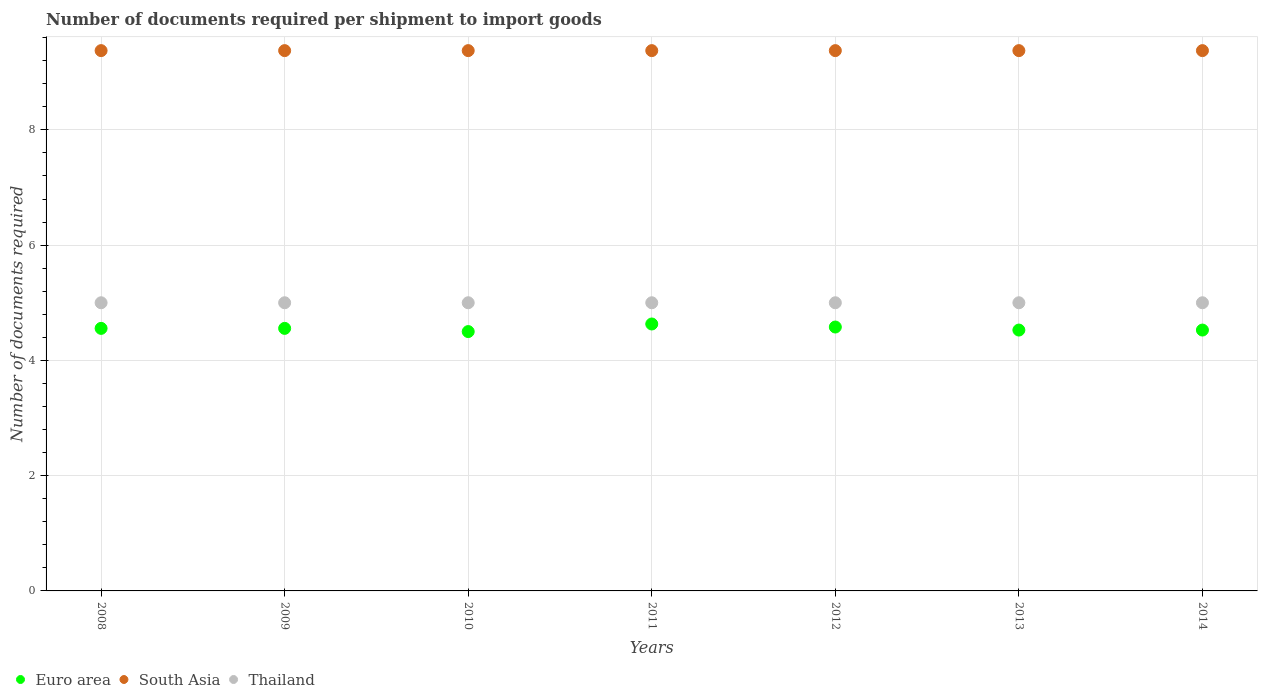How many different coloured dotlines are there?
Provide a succinct answer. 3. Is the number of dotlines equal to the number of legend labels?
Keep it short and to the point. Yes. What is the number of documents required per shipment to import goods in South Asia in 2013?
Offer a very short reply. 9.38. Across all years, what is the maximum number of documents required per shipment to import goods in South Asia?
Keep it short and to the point. 9.38. Across all years, what is the minimum number of documents required per shipment to import goods in Euro area?
Your answer should be very brief. 4.5. In which year was the number of documents required per shipment to import goods in South Asia maximum?
Ensure brevity in your answer.  2008. In which year was the number of documents required per shipment to import goods in Thailand minimum?
Make the answer very short. 2008. What is the total number of documents required per shipment to import goods in Thailand in the graph?
Give a very brief answer. 35. What is the difference between the number of documents required per shipment to import goods in Thailand in 2014 and the number of documents required per shipment to import goods in South Asia in 2012?
Your response must be concise. -4.38. What is the average number of documents required per shipment to import goods in Euro area per year?
Your answer should be very brief. 4.55. In the year 2012, what is the difference between the number of documents required per shipment to import goods in Thailand and number of documents required per shipment to import goods in South Asia?
Make the answer very short. -4.38. In how many years, is the number of documents required per shipment to import goods in Euro area greater than 2?
Offer a terse response. 7. Is the difference between the number of documents required per shipment to import goods in Thailand in 2008 and 2014 greater than the difference between the number of documents required per shipment to import goods in South Asia in 2008 and 2014?
Keep it short and to the point. No. What is the difference between the highest and the second highest number of documents required per shipment to import goods in Thailand?
Your answer should be compact. 0. Is the sum of the number of documents required per shipment to import goods in Thailand in 2008 and 2010 greater than the maximum number of documents required per shipment to import goods in South Asia across all years?
Ensure brevity in your answer.  Yes. Does the number of documents required per shipment to import goods in Thailand monotonically increase over the years?
Your response must be concise. No. What is the difference between two consecutive major ticks on the Y-axis?
Provide a short and direct response. 2. Does the graph contain grids?
Make the answer very short. Yes. How many legend labels are there?
Provide a short and direct response. 3. How are the legend labels stacked?
Your response must be concise. Horizontal. What is the title of the graph?
Your answer should be very brief. Number of documents required per shipment to import goods. Does "Rwanda" appear as one of the legend labels in the graph?
Your answer should be very brief. No. What is the label or title of the X-axis?
Offer a very short reply. Years. What is the label or title of the Y-axis?
Give a very brief answer. Number of documents required. What is the Number of documents required of Euro area in 2008?
Your answer should be compact. 4.56. What is the Number of documents required of South Asia in 2008?
Provide a short and direct response. 9.38. What is the Number of documents required in Thailand in 2008?
Your response must be concise. 5. What is the Number of documents required of Euro area in 2009?
Your answer should be very brief. 4.56. What is the Number of documents required in South Asia in 2009?
Ensure brevity in your answer.  9.38. What is the Number of documents required of South Asia in 2010?
Offer a terse response. 9.38. What is the Number of documents required of Euro area in 2011?
Your answer should be very brief. 4.63. What is the Number of documents required of South Asia in 2011?
Keep it short and to the point. 9.38. What is the Number of documents required in Euro area in 2012?
Provide a short and direct response. 4.58. What is the Number of documents required in South Asia in 2012?
Your response must be concise. 9.38. What is the Number of documents required of Euro area in 2013?
Keep it short and to the point. 4.53. What is the Number of documents required in South Asia in 2013?
Make the answer very short. 9.38. What is the Number of documents required in Euro area in 2014?
Ensure brevity in your answer.  4.53. What is the Number of documents required in South Asia in 2014?
Provide a succinct answer. 9.38. Across all years, what is the maximum Number of documents required in Euro area?
Your answer should be very brief. 4.63. Across all years, what is the maximum Number of documents required of South Asia?
Provide a short and direct response. 9.38. Across all years, what is the minimum Number of documents required in South Asia?
Give a very brief answer. 9.38. Across all years, what is the minimum Number of documents required of Thailand?
Offer a very short reply. 5. What is the total Number of documents required in Euro area in the graph?
Provide a short and direct response. 31.87. What is the total Number of documents required in South Asia in the graph?
Provide a short and direct response. 65.62. What is the total Number of documents required of Thailand in the graph?
Give a very brief answer. 35. What is the difference between the Number of documents required in South Asia in 2008 and that in 2009?
Keep it short and to the point. 0. What is the difference between the Number of documents required of Euro area in 2008 and that in 2010?
Your answer should be very brief. 0.06. What is the difference between the Number of documents required in Thailand in 2008 and that in 2010?
Provide a short and direct response. 0. What is the difference between the Number of documents required of Euro area in 2008 and that in 2011?
Ensure brevity in your answer.  -0.08. What is the difference between the Number of documents required in South Asia in 2008 and that in 2011?
Keep it short and to the point. 0. What is the difference between the Number of documents required in Euro area in 2008 and that in 2012?
Ensure brevity in your answer.  -0.02. What is the difference between the Number of documents required in South Asia in 2008 and that in 2012?
Give a very brief answer. 0. What is the difference between the Number of documents required in Thailand in 2008 and that in 2012?
Offer a terse response. 0. What is the difference between the Number of documents required in Euro area in 2008 and that in 2013?
Make the answer very short. 0.03. What is the difference between the Number of documents required of Euro area in 2008 and that in 2014?
Provide a succinct answer. 0.03. What is the difference between the Number of documents required in South Asia in 2008 and that in 2014?
Your answer should be compact. 0. What is the difference between the Number of documents required in Euro area in 2009 and that in 2010?
Keep it short and to the point. 0.06. What is the difference between the Number of documents required of South Asia in 2009 and that in 2010?
Make the answer very short. 0. What is the difference between the Number of documents required in Euro area in 2009 and that in 2011?
Keep it short and to the point. -0.08. What is the difference between the Number of documents required of South Asia in 2009 and that in 2011?
Keep it short and to the point. 0. What is the difference between the Number of documents required of Euro area in 2009 and that in 2012?
Your response must be concise. -0.02. What is the difference between the Number of documents required of Thailand in 2009 and that in 2012?
Make the answer very short. 0. What is the difference between the Number of documents required of Euro area in 2009 and that in 2013?
Your answer should be very brief. 0.03. What is the difference between the Number of documents required of Euro area in 2009 and that in 2014?
Offer a very short reply. 0.03. What is the difference between the Number of documents required of South Asia in 2009 and that in 2014?
Ensure brevity in your answer.  0. What is the difference between the Number of documents required in Thailand in 2009 and that in 2014?
Offer a very short reply. 0. What is the difference between the Number of documents required of Euro area in 2010 and that in 2011?
Make the answer very short. -0.13. What is the difference between the Number of documents required in Thailand in 2010 and that in 2011?
Ensure brevity in your answer.  0. What is the difference between the Number of documents required in Euro area in 2010 and that in 2012?
Offer a very short reply. -0.08. What is the difference between the Number of documents required of Euro area in 2010 and that in 2013?
Keep it short and to the point. -0.03. What is the difference between the Number of documents required in Thailand in 2010 and that in 2013?
Offer a very short reply. 0. What is the difference between the Number of documents required of Euro area in 2010 and that in 2014?
Offer a terse response. -0.03. What is the difference between the Number of documents required of South Asia in 2010 and that in 2014?
Ensure brevity in your answer.  0. What is the difference between the Number of documents required of Thailand in 2010 and that in 2014?
Offer a very short reply. 0. What is the difference between the Number of documents required of Euro area in 2011 and that in 2012?
Offer a terse response. 0.05. What is the difference between the Number of documents required of South Asia in 2011 and that in 2012?
Provide a short and direct response. 0. What is the difference between the Number of documents required of Euro area in 2011 and that in 2013?
Give a very brief answer. 0.11. What is the difference between the Number of documents required in South Asia in 2011 and that in 2013?
Your answer should be compact. 0. What is the difference between the Number of documents required in Euro area in 2011 and that in 2014?
Give a very brief answer. 0.11. What is the difference between the Number of documents required in South Asia in 2011 and that in 2014?
Keep it short and to the point. 0. What is the difference between the Number of documents required of Euro area in 2012 and that in 2013?
Your response must be concise. 0.05. What is the difference between the Number of documents required of South Asia in 2012 and that in 2013?
Provide a short and direct response. 0. What is the difference between the Number of documents required in Euro area in 2012 and that in 2014?
Offer a very short reply. 0.05. What is the difference between the Number of documents required of South Asia in 2013 and that in 2014?
Provide a succinct answer. 0. What is the difference between the Number of documents required of Thailand in 2013 and that in 2014?
Ensure brevity in your answer.  0. What is the difference between the Number of documents required in Euro area in 2008 and the Number of documents required in South Asia in 2009?
Provide a short and direct response. -4.82. What is the difference between the Number of documents required in Euro area in 2008 and the Number of documents required in Thailand in 2009?
Give a very brief answer. -0.44. What is the difference between the Number of documents required of South Asia in 2008 and the Number of documents required of Thailand in 2009?
Your response must be concise. 4.38. What is the difference between the Number of documents required in Euro area in 2008 and the Number of documents required in South Asia in 2010?
Make the answer very short. -4.82. What is the difference between the Number of documents required of Euro area in 2008 and the Number of documents required of Thailand in 2010?
Ensure brevity in your answer.  -0.44. What is the difference between the Number of documents required in South Asia in 2008 and the Number of documents required in Thailand in 2010?
Provide a short and direct response. 4.38. What is the difference between the Number of documents required of Euro area in 2008 and the Number of documents required of South Asia in 2011?
Your answer should be compact. -4.82. What is the difference between the Number of documents required of Euro area in 2008 and the Number of documents required of Thailand in 2011?
Your response must be concise. -0.44. What is the difference between the Number of documents required in South Asia in 2008 and the Number of documents required in Thailand in 2011?
Provide a succinct answer. 4.38. What is the difference between the Number of documents required in Euro area in 2008 and the Number of documents required in South Asia in 2012?
Provide a short and direct response. -4.82. What is the difference between the Number of documents required in Euro area in 2008 and the Number of documents required in Thailand in 2012?
Offer a terse response. -0.44. What is the difference between the Number of documents required of South Asia in 2008 and the Number of documents required of Thailand in 2012?
Provide a short and direct response. 4.38. What is the difference between the Number of documents required in Euro area in 2008 and the Number of documents required in South Asia in 2013?
Give a very brief answer. -4.82. What is the difference between the Number of documents required in Euro area in 2008 and the Number of documents required in Thailand in 2013?
Give a very brief answer. -0.44. What is the difference between the Number of documents required in South Asia in 2008 and the Number of documents required in Thailand in 2013?
Keep it short and to the point. 4.38. What is the difference between the Number of documents required of Euro area in 2008 and the Number of documents required of South Asia in 2014?
Ensure brevity in your answer.  -4.82. What is the difference between the Number of documents required of Euro area in 2008 and the Number of documents required of Thailand in 2014?
Your answer should be very brief. -0.44. What is the difference between the Number of documents required of South Asia in 2008 and the Number of documents required of Thailand in 2014?
Give a very brief answer. 4.38. What is the difference between the Number of documents required in Euro area in 2009 and the Number of documents required in South Asia in 2010?
Offer a very short reply. -4.82. What is the difference between the Number of documents required of Euro area in 2009 and the Number of documents required of Thailand in 2010?
Offer a terse response. -0.44. What is the difference between the Number of documents required in South Asia in 2009 and the Number of documents required in Thailand in 2010?
Provide a succinct answer. 4.38. What is the difference between the Number of documents required of Euro area in 2009 and the Number of documents required of South Asia in 2011?
Your response must be concise. -4.82. What is the difference between the Number of documents required of Euro area in 2009 and the Number of documents required of Thailand in 2011?
Offer a very short reply. -0.44. What is the difference between the Number of documents required of South Asia in 2009 and the Number of documents required of Thailand in 2011?
Your answer should be compact. 4.38. What is the difference between the Number of documents required in Euro area in 2009 and the Number of documents required in South Asia in 2012?
Ensure brevity in your answer.  -4.82. What is the difference between the Number of documents required in Euro area in 2009 and the Number of documents required in Thailand in 2012?
Provide a succinct answer. -0.44. What is the difference between the Number of documents required in South Asia in 2009 and the Number of documents required in Thailand in 2012?
Your response must be concise. 4.38. What is the difference between the Number of documents required in Euro area in 2009 and the Number of documents required in South Asia in 2013?
Provide a short and direct response. -4.82. What is the difference between the Number of documents required of Euro area in 2009 and the Number of documents required of Thailand in 2013?
Offer a very short reply. -0.44. What is the difference between the Number of documents required in South Asia in 2009 and the Number of documents required in Thailand in 2013?
Ensure brevity in your answer.  4.38. What is the difference between the Number of documents required of Euro area in 2009 and the Number of documents required of South Asia in 2014?
Keep it short and to the point. -4.82. What is the difference between the Number of documents required of Euro area in 2009 and the Number of documents required of Thailand in 2014?
Offer a terse response. -0.44. What is the difference between the Number of documents required in South Asia in 2009 and the Number of documents required in Thailand in 2014?
Provide a short and direct response. 4.38. What is the difference between the Number of documents required of Euro area in 2010 and the Number of documents required of South Asia in 2011?
Offer a very short reply. -4.88. What is the difference between the Number of documents required in Euro area in 2010 and the Number of documents required in Thailand in 2011?
Offer a terse response. -0.5. What is the difference between the Number of documents required in South Asia in 2010 and the Number of documents required in Thailand in 2011?
Offer a very short reply. 4.38. What is the difference between the Number of documents required in Euro area in 2010 and the Number of documents required in South Asia in 2012?
Provide a short and direct response. -4.88. What is the difference between the Number of documents required of South Asia in 2010 and the Number of documents required of Thailand in 2012?
Keep it short and to the point. 4.38. What is the difference between the Number of documents required in Euro area in 2010 and the Number of documents required in South Asia in 2013?
Ensure brevity in your answer.  -4.88. What is the difference between the Number of documents required in Euro area in 2010 and the Number of documents required in Thailand in 2013?
Your answer should be very brief. -0.5. What is the difference between the Number of documents required in South Asia in 2010 and the Number of documents required in Thailand in 2013?
Make the answer very short. 4.38. What is the difference between the Number of documents required in Euro area in 2010 and the Number of documents required in South Asia in 2014?
Give a very brief answer. -4.88. What is the difference between the Number of documents required in South Asia in 2010 and the Number of documents required in Thailand in 2014?
Keep it short and to the point. 4.38. What is the difference between the Number of documents required of Euro area in 2011 and the Number of documents required of South Asia in 2012?
Provide a succinct answer. -4.74. What is the difference between the Number of documents required in Euro area in 2011 and the Number of documents required in Thailand in 2012?
Offer a very short reply. -0.37. What is the difference between the Number of documents required of South Asia in 2011 and the Number of documents required of Thailand in 2012?
Offer a very short reply. 4.38. What is the difference between the Number of documents required of Euro area in 2011 and the Number of documents required of South Asia in 2013?
Provide a succinct answer. -4.74. What is the difference between the Number of documents required in Euro area in 2011 and the Number of documents required in Thailand in 2013?
Your answer should be compact. -0.37. What is the difference between the Number of documents required in South Asia in 2011 and the Number of documents required in Thailand in 2013?
Your answer should be compact. 4.38. What is the difference between the Number of documents required in Euro area in 2011 and the Number of documents required in South Asia in 2014?
Provide a short and direct response. -4.74. What is the difference between the Number of documents required of Euro area in 2011 and the Number of documents required of Thailand in 2014?
Your answer should be compact. -0.37. What is the difference between the Number of documents required of South Asia in 2011 and the Number of documents required of Thailand in 2014?
Your answer should be very brief. 4.38. What is the difference between the Number of documents required of Euro area in 2012 and the Number of documents required of South Asia in 2013?
Offer a very short reply. -4.8. What is the difference between the Number of documents required of Euro area in 2012 and the Number of documents required of Thailand in 2013?
Provide a succinct answer. -0.42. What is the difference between the Number of documents required of South Asia in 2012 and the Number of documents required of Thailand in 2013?
Make the answer very short. 4.38. What is the difference between the Number of documents required in Euro area in 2012 and the Number of documents required in South Asia in 2014?
Your answer should be compact. -4.8. What is the difference between the Number of documents required in Euro area in 2012 and the Number of documents required in Thailand in 2014?
Your answer should be very brief. -0.42. What is the difference between the Number of documents required in South Asia in 2012 and the Number of documents required in Thailand in 2014?
Your answer should be compact. 4.38. What is the difference between the Number of documents required of Euro area in 2013 and the Number of documents required of South Asia in 2014?
Ensure brevity in your answer.  -4.85. What is the difference between the Number of documents required in Euro area in 2013 and the Number of documents required in Thailand in 2014?
Offer a terse response. -0.47. What is the difference between the Number of documents required of South Asia in 2013 and the Number of documents required of Thailand in 2014?
Ensure brevity in your answer.  4.38. What is the average Number of documents required of Euro area per year?
Offer a terse response. 4.55. What is the average Number of documents required in South Asia per year?
Offer a terse response. 9.38. What is the average Number of documents required of Thailand per year?
Make the answer very short. 5. In the year 2008, what is the difference between the Number of documents required of Euro area and Number of documents required of South Asia?
Provide a succinct answer. -4.82. In the year 2008, what is the difference between the Number of documents required of Euro area and Number of documents required of Thailand?
Offer a very short reply. -0.44. In the year 2008, what is the difference between the Number of documents required in South Asia and Number of documents required in Thailand?
Offer a terse response. 4.38. In the year 2009, what is the difference between the Number of documents required of Euro area and Number of documents required of South Asia?
Provide a succinct answer. -4.82. In the year 2009, what is the difference between the Number of documents required of Euro area and Number of documents required of Thailand?
Offer a terse response. -0.44. In the year 2009, what is the difference between the Number of documents required of South Asia and Number of documents required of Thailand?
Your response must be concise. 4.38. In the year 2010, what is the difference between the Number of documents required in Euro area and Number of documents required in South Asia?
Offer a terse response. -4.88. In the year 2010, what is the difference between the Number of documents required of South Asia and Number of documents required of Thailand?
Your response must be concise. 4.38. In the year 2011, what is the difference between the Number of documents required of Euro area and Number of documents required of South Asia?
Provide a succinct answer. -4.74. In the year 2011, what is the difference between the Number of documents required in Euro area and Number of documents required in Thailand?
Give a very brief answer. -0.37. In the year 2011, what is the difference between the Number of documents required of South Asia and Number of documents required of Thailand?
Your response must be concise. 4.38. In the year 2012, what is the difference between the Number of documents required in Euro area and Number of documents required in South Asia?
Give a very brief answer. -4.8. In the year 2012, what is the difference between the Number of documents required of Euro area and Number of documents required of Thailand?
Ensure brevity in your answer.  -0.42. In the year 2012, what is the difference between the Number of documents required of South Asia and Number of documents required of Thailand?
Your answer should be compact. 4.38. In the year 2013, what is the difference between the Number of documents required of Euro area and Number of documents required of South Asia?
Make the answer very short. -4.85. In the year 2013, what is the difference between the Number of documents required in Euro area and Number of documents required in Thailand?
Your response must be concise. -0.47. In the year 2013, what is the difference between the Number of documents required in South Asia and Number of documents required in Thailand?
Your answer should be very brief. 4.38. In the year 2014, what is the difference between the Number of documents required of Euro area and Number of documents required of South Asia?
Your answer should be very brief. -4.85. In the year 2014, what is the difference between the Number of documents required in Euro area and Number of documents required in Thailand?
Make the answer very short. -0.47. In the year 2014, what is the difference between the Number of documents required of South Asia and Number of documents required of Thailand?
Ensure brevity in your answer.  4.38. What is the ratio of the Number of documents required in South Asia in 2008 to that in 2009?
Offer a terse response. 1. What is the ratio of the Number of documents required of Thailand in 2008 to that in 2009?
Make the answer very short. 1. What is the ratio of the Number of documents required in Euro area in 2008 to that in 2010?
Ensure brevity in your answer.  1.01. What is the ratio of the Number of documents required in South Asia in 2008 to that in 2010?
Your answer should be compact. 1. What is the ratio of the Number of documents required of Thailand in 2008 to that in 2010?
Provide a short and direct response. 1. What is the ratio of the Number of documents required of Euro area in 2008 to that in 2011?
Your answer should be very brief. 0.98. What is the ratio of the Number of documents required of South Asia in 2008 to that in 2011?
Keep it short and to the point. 1. What is the ratio of the Number of documents required of Euro area in 2008 to that in 2012?
Offer a very short reply. 0.99. What is the ratio of the Number of documents required of Thailand in 2008 to that in 2012?
Keep it short and to the point. 1. What is the ratio of the Number of documents required in Euro area in 2008 to that in 2014?
Your response must be concise. 1.01. What is the ratio of the Number of documents required in South Asia in 2008 to that in 2014?
Give a very brief answer. 1. What is the ratio of the Number of documents required in Thailand in 2008 to that in 2014?
Your response must be concise. 1. What is the ratio of the Number of documents required of Euro area in 2009 to that in 2010?
Your response must be concise. 1.01. What is the ratio of the Number of documents required of Thailand in 2009 to that in 2010?
Provide a succinct answer. 1. What is the ratio of the Number of documents required in Euro area in 2009 to that in 2011?
Provide a short and direct response. 0.98. What is the ratio of the Number of documents required in South Asia in 2009 to that in 2012?
Your answer should be compact. 1. What is the ratio of the Number of documents required of Thailand in 2009 to that in 2012?
Provide a short and direct response. 1. What is the ratio of the Number of documents required in Euro area in 2009 to that in 2013?
Make the answer very short. 1.01. What is the ratio of the Number of documents required of Thailand in 2009 to that in 2013?
Your answer should be compact. 1. What is the ratio of the Number of documents required in Euro area in 2009 to that in 2014?
Keep it short and to the point. 1.01. What is the ratio of the Number of documents required of South Asia in 2009 to that in 2014?
Give a very brief answer. 1. What is the ratio of the Number of documents required in Euro area in 2010 to that in 2011?
Ensure brevity in your answer.  0.97. What is the ratio of the Number of documents required of Euro area in 2010 to that in 2012?
Keep it short and to the point. 0.98. What is the ratio of the Number of documents required in South Asia in 2010 to that in 2012?
Offer a terse response. 1. What is the ratio of the Number of documents required of Euro area in 2010 to that in 2013?
Make the answer very short. 0.99. What is the ratio of the Number of documents required in Euro area in 2010 to that in 2014?
Offer a very short reply. 0.99. What is the ratio of the Number of documents required of South Asia in 2010 to that in 2014?
Keep it short and to the point. 1. What is the ratio of the Number of documents required in Thailand in 2010 to that in 2014?
Your answer should be compact. 1. What is the ratio of the Number of documents required of Euro area in 2011 to that in 2012?
Offer a terse response. 1.01. What is the ratio of the Number of documents required of South Asia in 2011 to that in 2012?
Your answer should be very brief. 1. What is the ratio of the Number of documents required of Thailand in 2011 to that in 2012?
Your answer should be very brief. 1. What is the ratio of the Number of documents required of Euro area in 2011 to that in 2013?
Offer a very short reply. 1.02. What is the ratio of the Number of documents required of Thailand in 2011 to that in 2013?
Keep it short and to the point. 1. What is the ratio of the Number of documents required in Euro area in 2011 to that in 2014?
Make the answer very short. 1.02. What is the ratio of the Number of documents required of South Asia in 2011 to that in 2014?
Keep it short and to the point. 1. What is the ratio of the Number of documents required of Euro area in 2012 to that in 2013?
Ensure brevity in your answer.  1.01. What is the ratio of the Number of documents required of South Asia in 2012 to that in 2013?
Provide a short and direct response. 1. What is the ratio of the Number of documents required in Euro area in 2012 to that in 2014?
Give a very brief answer. 1.01. What is the ratio of the Number of documents required in South Asia in 2012 to that in 2014?
Offer a terse response. 1. What is the ratio of the Number of documents required of Euro area in 2013 to that in 2014?
Offer a very short reply. 1. What is the ratio of the Number of documents required in Thailand in 2013 to that in 2014?
Make the answer very short. 1. What is the difference between the highest and the second highest Number of documents required of Euro area?
Offer a very short reply. 0.05. What is the difference between the highest and the second highest Number of documents required of Thailand?
Your answer should be very brief. 0. What is the difference between the highest and the lowest Number of documents required in Euro area?
Offer a terse response. 0.13. What is the difference between the highest and the lowest Number of documents required in Thailand?
Provide a short and direct response. 0. 